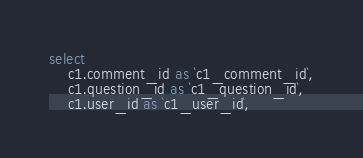<code> <loc_0><loc_0><loc_500><loc_500><_SQL_>select
    c1.comment_id as `c1_comment_id`,
    c1.question_id as `c1_question_id`,
    c1.user_id as `c1_user_id`,</code> 